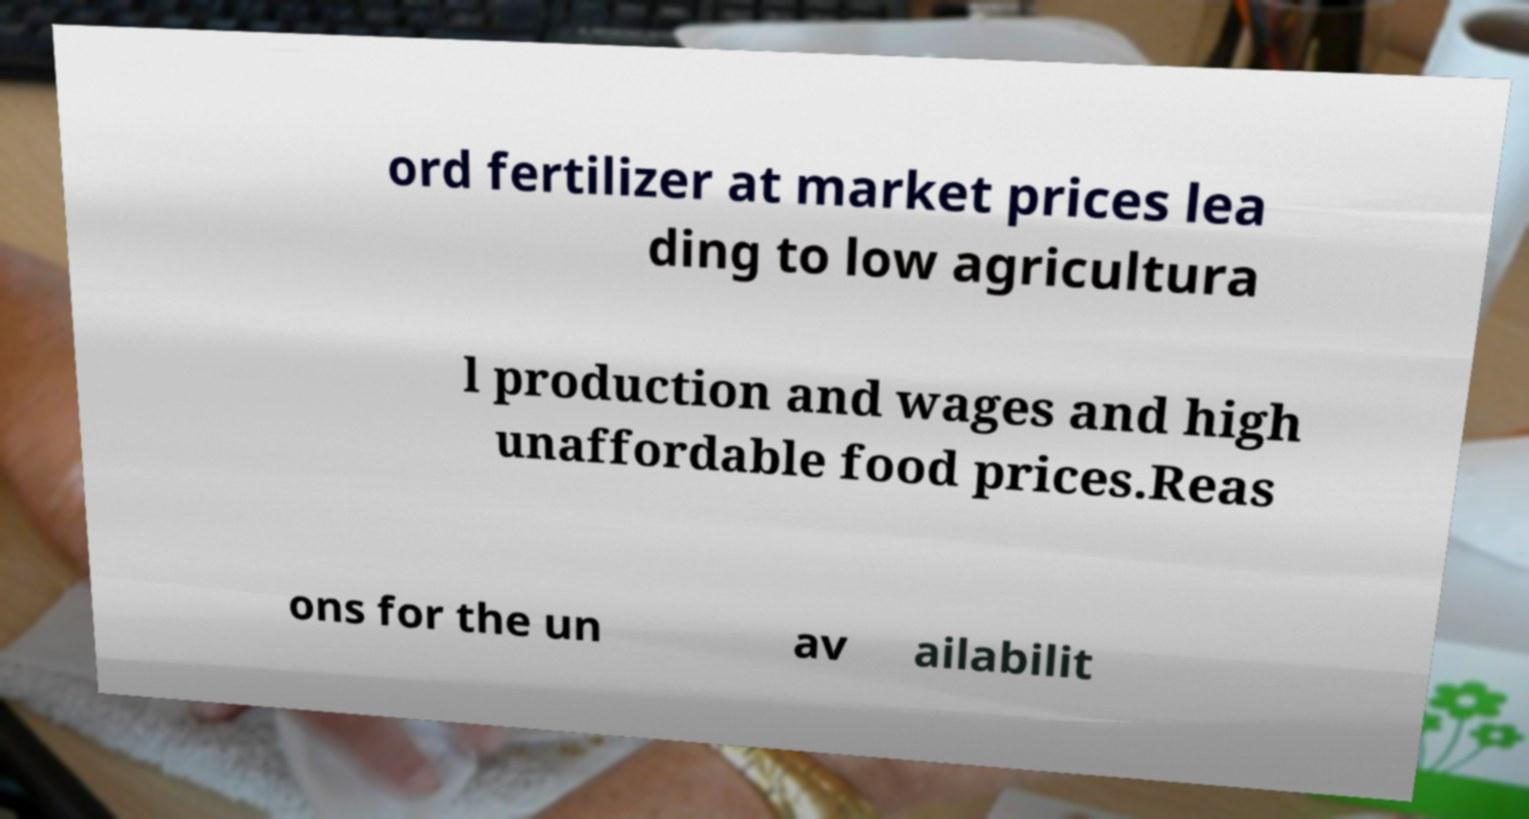Can you accurately transcribe the text from the provided image for me? ord fertilizer at market prices lea ding to low agricultura l production and wages and high unaffordable food prices.Reas ons for the un av ailabilit 